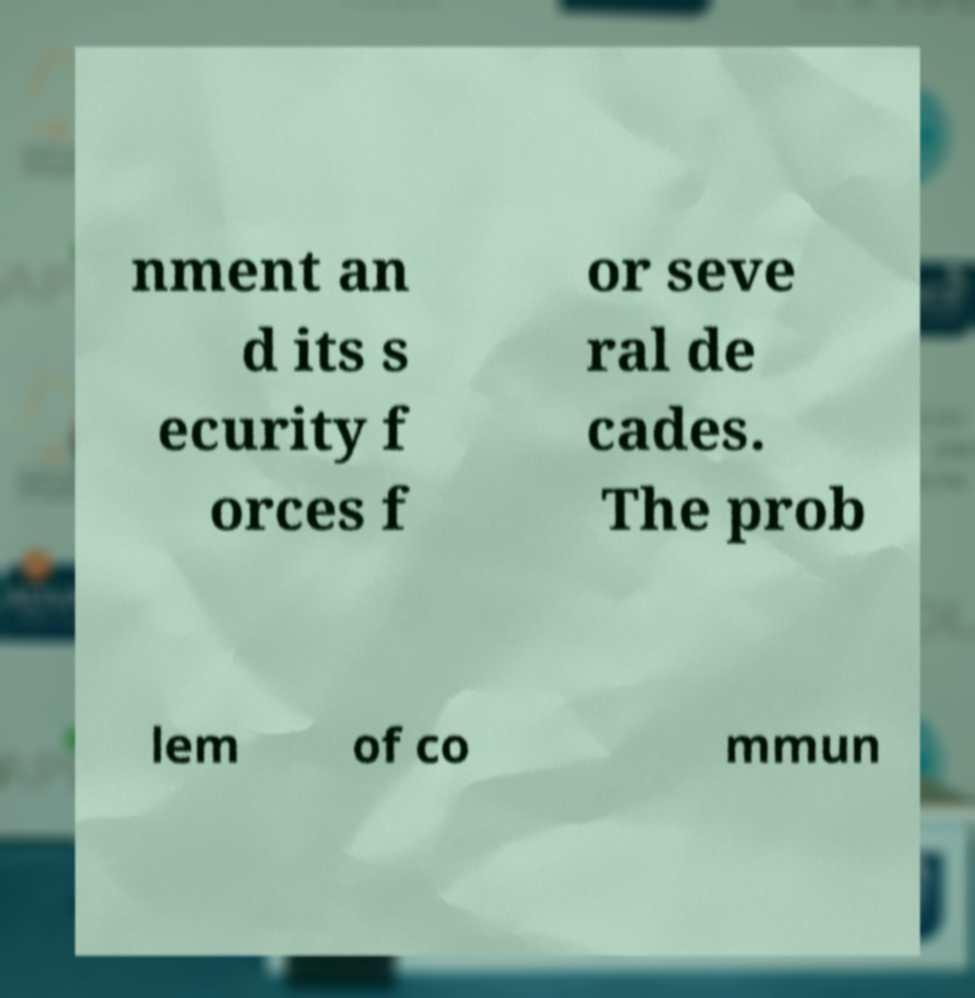There's text embedded in this image that I need extracted. Can you transcribe it verbatim? nment an d its s ecurity f orces f or seve ral de cades. The prob lem of co mmun 